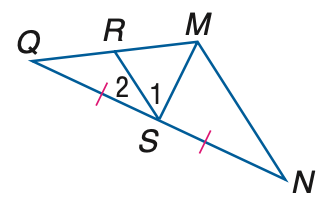Answer the mathemtical geometry problem and directly provide the correct option letter.
Question: Find x if M S is an altitude of \triangle M N Q, m \angle 1 = 3 x + 11, and m \angle 2 = 7 x + 9.
Choices: A: 5 B: 7 C: 9 D: 11 B 